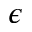Convert formula to latex. <formula><loc_0><loc_0><loc_500><loc_500>\epsilon</formula> 